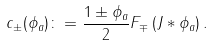Convert formula to latex. <formula><loc_0><loc_0><loc_500><loc_500>c _ { \pm } ( \phi _ { a } ) \colon = \frac { 1 \pm \phi _ { a } } { 2 } F _ { \mp } \left ( J * \phi _ { a } \right ) .</formula> 